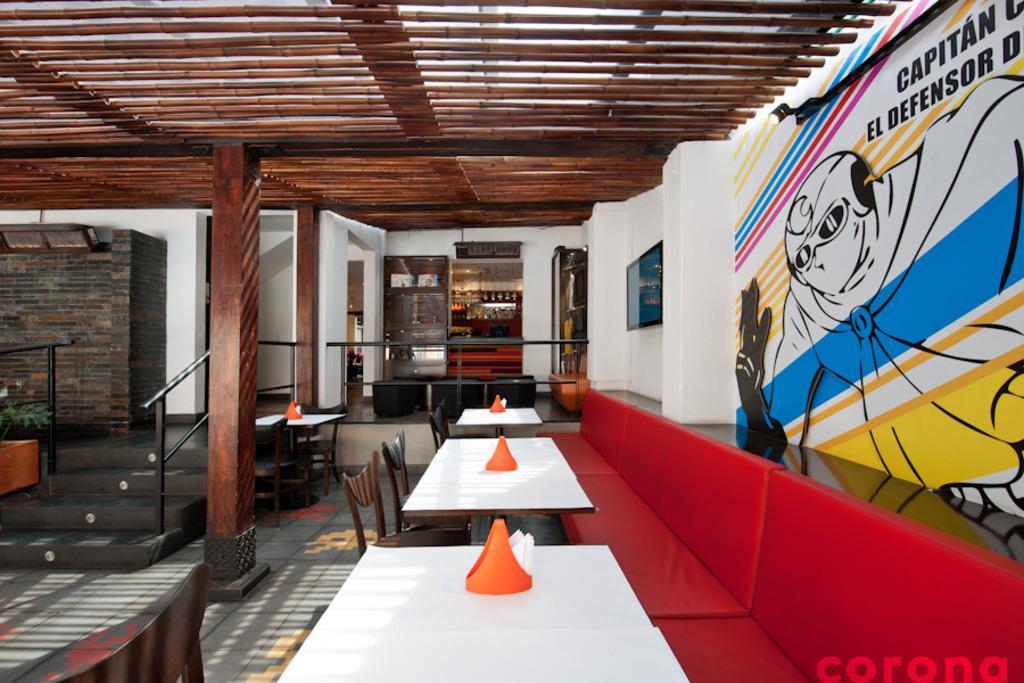Describe this image in one or two sentences. This is a building looks like a restaurant. On the right there are 3 sofas,tables and chair and tissue box on the table. On the right wall there is a painting and a frame and a light on it. On the left we can see the entrance to the room, we have steps there and fence. At the rooftop there is a wooden designed roof top. 